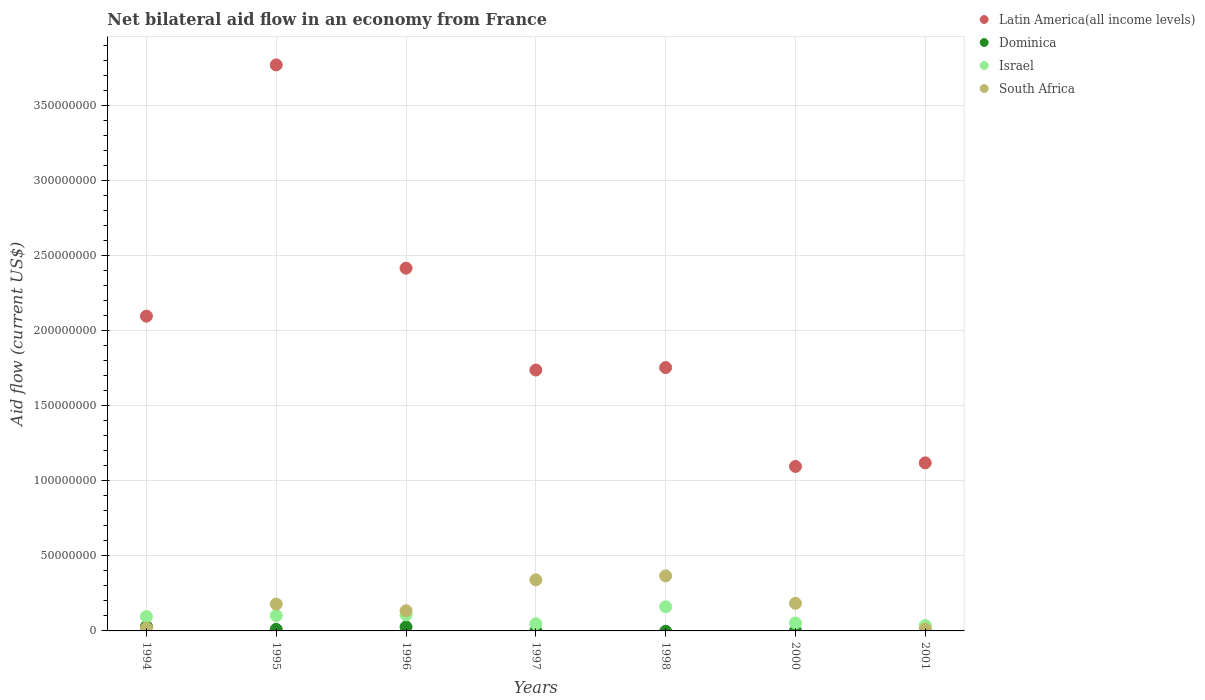How many different coloured dotlines are there?
Provide a succinct answer. 4. What is the net bilateral aid flow in South Africa in 1994?
Offer a terse response. 1.88e+06. Across all years, what is the maximum net bilateral aid flow in Dominica?
Make the answer very short. 2.91e+06. What is the total net bilateral aid flow in Israel in the graph?
Ensure brevity in your answer.  6.02e+07. What is the difference between the net bilateral aid flow in Latin America(all income levels) in 1994 and that in 1998?
Make the answer very short. 3.42e+07. What is the difference between the net bilateral aid flow in Latin America(all income levels) in 1995 and the net bilateral aid flow in Israel in 1997?
Keep it short and to the point. 3.72e+08. What is the average net bilateral aid flow in Latin America(all income levels) per year?
Make the answer very short. 2.00e+08. In the year 1997, what is the difference between the net bilateral aid flow in Dominica and net bilateral aid flow in Israel?
Your answer should be very brief. -4.63e+06. In how many years, is the net bilateral aid flow in South Africa greater than 50000000 US$?
Provide a short and direct response. 0. What is the ratio of the net bilateral aid flow in South Africa in 1997 to that in 1998?
Keep it short and to the point. 0.93. Is the difference between the net bilateral aid flow in Dominica in 1994 and 1995 greater than the difference between the net bilateral aid flow in Israel in 1994 and 1995?
Provide a short and direct response. Yes. What is the difference between the highest and the second highest net bilateral aid flow in South Africa?
Offer a very short reply. 2.65e+06. What is the difference between the highest and the lowest net bilateral aid flow in Israel?
Offer a very short reply. 1.25e+07. In how many years, is the net bilateral aid flow in South Africa greater than the average net bilateral aid flow in South Africa taken over all years?
Keep it short and to the point. 4. Is it the case that in every year, the sum of the net bilateral aid flow in Dominica and net bilateral aid flow in Israel  is greater than the net bilateral aid flow in South Africa?
Your response must be concise. No. Does the net bilateral aid flow in Israel monotonically increase over the years?
Offer a very short reply. No. Is the net bilateral aid flow in Latin America(all income levels) strictly greater than the net bilateral aid flow in Israel over the years?
Provide a short and direct response. Yes. How many years are there in the graph?
Provide a succinct answer. 7. What is the difference between two consecutive major ticks on the Y-axis?
Provide a succinct answer. 5.00e+07. Does the graph contain any zero values?
Offer a terse response. Yes. Does the graph contain grids?
Offer a very short reply. Yes. Where does the legend appear in the graph?
Your answer should be very brief. Top right. How many legend labels are there?
Provide a short and direct response. 4. What is the title of the graph?
Give a very brief answer. Net bilateral aid flow in an economy from France. What is the label or title of the X-axis?
Provide a succinct answer. Years. What is the label or title of the Y-axis?
Make the answer very short. Aid flow (current US$). What is the Aid flow (current US$) in Latin America(all income levels) in 1994?
Offer a very short reply. 2.10e+08. What is the Aid flow (current US$) in Dominica in 1994?
Provide a succinct answer. 2.91e+06. What is the Aid flow (current US$) of Israel in 1994?
Offer a very short reply. 9.57e+06. What is the Aid flow (current US$) in South Africa in 1994?
Offer a terse response. 1.88e+06. What is the Aid flow (current US$) in Latin America(all income levels) in 1995?
Provide a succinct answer. 3.77e+08. What is the Aid flow (current US$) in Dominica in 1995?
Your response must be concise. 1.05e+06. What is the Aid flow (current US$) in Israel in 1995?
Make the answer very short. 1.02e+07. What is the Aid flow (current US$) of South Africa in 1995?
Ensure brevity in your answer.  1.79e+07. What is the Aid flow (current US$) of Latin America(all income levels) in 1996?
Keep it short and to the point. 2.41e+08. What is the Aid flow (current US$) of Dominica in 1996?
Ensure brevity in your answer.  2.66e+06. What is the Aid flow (current US$) of Israel in 1996?
Ensure brevity in your answer.  1.07e+07. What is the Aid flow (current US$) of South Africa in 1996?
Ensure brevity in your answer.  1.34e+07. What is the Aid flow (current US$) in Latin America(all income levels) in 1997?
Offer a very short reply. 1.74e+08. What is the Aid flow (current US$) of Dominica in 1997?
Ensure brevity in your answer.  1.50e+05. What is the Aid flow (current US$) in Israel in 1997?
Offer a very short reply. 4.78e+06. What is the Aid flow (current US$) in South Africa in 1997?
Provide a short and direct response. 3.40e+07. What is the Aid flow (current US$) in Latin America(all income levels) in 1998?
Provide a succinct answer. 1.75e+08. What is the Aid flow (current US$) of Israel in 1998?
Your response must be concise. 1.61e+07. What is the Aid flow (current US$) of South Africa in 1998?
Make the answer very short. 3.67e+07. What is the Aid flow (current US$) of Latin America(all income levels) in 2000?
Your answer should be compact. 1.09e+08. What is the Aid flow (current US$) in Israel in 2000?
Your answer should be compact. 5.28e+06. What is the Aid flow (current US$) in South Africa in 2000?
Offer a very short reply. 1.84e+07. What is the Aid flow (current US$) in Latin America(all income levels) in 2001?
Give a very brief answer. 1.12e+08. What is the Aid flow (current US$) in Dominica in 2001?
Ensure brevity in your answer.  0. What is the Aid flow (current US$) in Israel in 2001?
Offer a terse response. 3.59e+06. What is the Aid flow (current US$) in South Africa in 2001?
Keep it short and to the point. 1.27e+06. Across all years, what is the maximum Aid flow (current US$) of Latin America(all income levels)?
Make the answer very short. 3.77e+08. Across all years, what is the maximum Aid flow (current US$) in Dominica?
Offer a very short reply. 2.91e+06. Across all years, what is the maximum Aid flow (current US$) in Israel?
Your answer should be very brief. 1.61e+07. Across all years, what is the maximum Aid flow (current US$) in South Africa?
Your answer should be very brief. 3.67e+07. Across all years, what is the minimum Aid flow (current US$) of Latin America(all income levels)?
Ensure brevity in your answer.  1.09e+08. Across all years, what is the minimum Aid flow (current US$) of Israel?
Offer a very short reply. 3.59e+06. Across all years, what is the minimum Aid flow (current US$) of South Africa?
Ensure brevity in your answer.  1.27e+06. What is the total Aid flow (current US$) in Latin America(all income levels) in the graph?
Provide a succinct answer. 1.40e+09. What is the total Aid flow (current US$) in Dominica in the graph?
Your answer should be compact. 6.80e+06. What is the total Aid flow (current US$) of Israel in the graph?
Keep it short and to the point. 6.02e+07. What is the total Aid flow (current US$) of South Africa in the graph?
Provide a short and direct response. 1.23e+08. What is the difference between the Aid flow (current US$) of Latin America(all income levels) in 1994 and that in 1995?
Make the answer very short. -1.67e+08. What is the difference between the Aid flow (current US$) of Dominica in 1994 and that in 1995?
Ensure brevity in your answer.  1.86e+06. What is the difference between the Aid flow (current US$) of Israel in 1994 and that in 1995?
Provide a short and direct response. -6.70e+05. What is the difference between the Aid flow (current US$) in South Africa in 1994 and that in 1995?
Your response must be concise. -1.60e+07. What is the difference between the Aid flow (current US$) in Latin America(all income levels) in 1994 and that in 1996?
Keep it short and to the point. -3.19e+07. What is the difference between the Aid flow (current US$) in Israel in 1994 and that in 1996?
Make the answer very short. -1.09e+06. What is the difference between the Aid flow (current US$) of South Africa in 1994 and that in 1996?
Your answer should be compact. -1.15e+07. What is the difference between the Aid flow (current US$) of Latin America(all income levels) in 1994 and that in 1997?
Provide a short and direct response. 3.58e+07. What is the difference between the Aid flow (current US$) in Dominica in 1994 and that in 1997?
Ensure brevity in your answer.  2.76e+06. What is the difference between the Aid flow (current US$) of Israel in 1994 and that in 1997?
Offer a terse response. 4.79e+06. What is the difference between the Aid flow (current US$) in South Africa in 1994 and that in 1997?
Your answer should be compact. -3.21e+07. What is the difference between the Aid flow (current US$) of Latin America(all income levels) in 1994 and that in 1998?
Ensure brevity in your answer.  3.42e+07. What is the difference between the Aid flow (current US$) of Israel in 1994 and that in 1998?
Provide a succinct answer. -6.52e+06. What is the difference between the Aid flow (current US$) of South Africa in 1994 and that in 1998?
Keep it short and to the point. -3.48e+07. What is the difference between the Aid flow (current US$) of Latin America(all income levels) in 1994 and that in 2000?
Provide a short and direct response. 1.00e+08. What is the difference between the Aid flow (current US$) in Dominica in 1994 and that in 2000?
Keep it short and to the point. 2.88e+06. What is the difference between the Aid flow (current US$) in Israel in 1994 and that in 2000?
Give a very brief answer. 4.29e+06. What is the difference between the Aid flow (current US$) in South Africa in 1994 and that in 2000?
Ensure brevity in your answer.  -1.65e+07. What is the difference between the Aid flow (current US$) of Latin America(all income levels) in 1994 and that in 2001?
Your response must be concise. 9.77e+07. What is the difference between the Aid flow (current US$) in Israel in 1994 and that in 2001?
Offer a very short reply. 5.98e+06. What is the difference between the Aid flow (current US$) of Latin America(all income levels) in 1995 and that in 1996?
Ensure brevity in your answer.  1.35e+08. What is the difference between the Aid flow (current US$) in Dominica in 1995 and that in 1996?
Your answer should be compact. -1.61e+06. What is the difference between the Aid flow (current US$) of Israel in 1995 and that in 1996?
Offer a terse response. -4.20e+05. What is the difference between the Aid flow (current US$) of South Africa in 1995 and that in 1996?
Your answer should be very brief. 4.44e+06. What is the difference between the Aid flow (current US$) of Latin America(all income levels) in 1995 and that in 1997?
Give a very brief answer. 2.03e+08. What is the difference between the Aid flow (current US$) in Dominica in 1995 and that in 1997?
Ensure brevity in your answer.  9.00e+05. What is the difference between the Aid flow (current US$) of Israel in 1995 and that in 1997?
Your answer should be very brief. 5.46e+06. What is the difference between the Aid flow (current US$) in South Africa in 1995 and that in 1997?
Ensure brevity in your answer.  -1.62e+07. What is the difference between the Aid flow (current US$) of Latin America(all income levels) in 1995 and that in 1998?
Offer a terse response. 2.01e+08. What is the difference between the Aid flow (current US$) in Israel in 1995 and that in 1998?
Provide a short and direct response. -5.85e+06. What is the difference between the Aid flow (current US$) in South Africa in 1995 and that in 1998?
Give a very brief answer. -1.88e+07. What is the difference between the Aid flow (current US$) of Latin America(all income levels) in 1995 and that in 2000?
Provide a succinct answer. 2.67e+08. What is the difference between the Aid flow (current US$) of Dominica in 1995 and that in 2000?
Make the answer very short. 1.02e+06. What is the difference between the Aid flow (current US$) of Israel in 1995 and that in 2000?
Keep it short and to the point. 4.96e+06. What is the difference between the Aid flow (current US$) in South Africa in 1995 and that in 2000?
Your answer should be compact. -5.00e+05. What is the difference between the Aid flow (current US$) of Latin America(all income levels) in 1995 and that in 2001?
Ensure brevity in your answer.  2.65e+08. What is the difference between the Aid flow (current US$) in Israel in 1995 and that in 2001?
Your answer should be compact. 6.65e+06. What is the difference between the Aid flow (current US$) of South Africa in 1995 and that in 2001?
Ensure brevity in your answer.  1.66e+07. What is the difference between the Aid flow (current US$) in Latin America(all income levels) in 1996 and that in 1997?
Provide a short and direct response. 6.78e+07. What is the difference between the Aid flow (current US$) of Dominica in 1996 and that in 1997?
Make the answer very short. 2.51e+06. What is the difference between the Aid flow (current US$) of Israel in 1996 and that in 1997?
Provide a short and direct response. 5.88e+06. What is the difference between the Aid flow (current US$) of South Africa in 1996 and that in 1997?
Your answer should be compact. -2.06e+07. What is the difference between the Aid flow (current US$) of Latin America(all income levels) in 1996 and that in 1998?
Provide a short and direct response. 6.62e+07. What is the difference between the Aid flow (current US$) of Israel in 1996 and that in 1998?
Ensure brevity in your answer.  -5.43e+06. What is the difference between the Aid flow (current US$) in South Africa in 1996 and that in 1998?
Your response must be concise. -2.32e+07. What is the difference between the Aid flow (current US$) of Latin America(all income levels) in 1996 and that in 2000?
Your answer should be compact. 1.32e+08. What is the difference between the Aid flow (current US$) in Dominica in 1996 and that in 2000?
Offer a very short reply. 2.63e+06. What is the difference between the Aid flow (current US$) in Israel in 1996 and that in 2000?
Your response must be concise. 5.38e+06. What is the difference between the Aid flow (current US$) of South Africa in 1996 and that in 2000?
Your answer should be compact. -4.94e+06. What is the difference between the Aid flow (current US$) in Latin America(all income levels) in 1996 and that in 2001?
Provide a short and direct response. 1.30e+08. What is the difference between the Aid flow (current US$) of Israel in 1996 and that in 2001?
Your response must be concise. 7.07e+06. What is the difference between the Aid flow (current US$) in South Africa in 1996 and that in 2001?
Your answer should be very brief. 1.22e+07. What is the difference between the Aid flow (current US$) of Latin America(all income levels) in 1997 and that in 1998?
Your answer should be compact. -1.63e+06. What is the difference between the Aid flow (current US$) of Israel in 1997 and that in 1998?
Your answer should be very brief. -1.13e+07. What is the difference between the Aid flow (current US$) in South Africa in 1997 and that in 1998?
Provide a short and direct response. -2.65e+06. What is the difference between the Aid flow (current US$) of Latin America(all income levels) in 1997 and that in 2000?
Ensure brevity in your answer.  6.42e+07. What is the difference between the Aid flow (current US$) in Dominica in 1997 and that in 2000?
Keep it short and to the point. 1.20e+05. What is the difference between the Aid flow (current US$) of Israel in 1997 and that in 2000?
Ensure brevity in your answer.  -5.00e+05. What is the difference between the Aid flow (current US$) of South Africa in 1997 and that in 2000?
Offer a very short reply. 1.56e+07. What is the difference between the Aid flow (current US$) of Latin America(all income levels) in 1997 and that in 2001?
Provide a succinct answer. 6.18e+07. What is the difference between the Aid flow (current US$) of Israel in 1997 and that in 2001?
Ensure brevity in your answer.  1.19e+06. What is the difference between the Aid flow (current US$) in South Africa in 1997 and that in 2001?
Your response must be concise. 3.27e+07. What is the difference between the Aid flow (current US$) in Latin America(all income levels) in 1998 and that in 2000?
Your response must be concise. 6.58e+07. What is the difference between the Aid flow (current US$) of Israel in 1998 and that in 2000?
Your answer should be compact. 1.08e+07. What is the difference between the Aid flow (current US$) of South Africa in 1998 and that in 2000?
Offer a terse response. 1.83e+07. What is the difference between the Aid flow (current US$) of Latin America(all income levels) in 1998 and that in 2001?
Ensure brevity in your answer.  6.34e+07. What is the difference between the Aid flow (current US$) in Israel in 1998 and that in 2001?
Offer a very short reply. 1.25e+07. What is the difference between the Aid flow (current US$) in South Africa in 1998 and that in 2001?
Give a very brief answer. 3.54e+07. What is the difference between the Aid flow (current US$) of Latin America(all income levels) in 2000 and that in 2001?
Provide a succinct answer. -2.40e+06. What is the difference between the Aid flow (current US$) of Israel in 2000 and that in 2001?
Ensure brevity in your answer.  1.69e+06. What is the difference between the Aid flow (current US$) in South Africa in 2000 and that in 2001?
Offer a terse response. 1.71e+07. What is the difference between the Aid flow (current US$) in Latin America(all income levels) in 1994 and the Aid flow (current US$) in Dominica in 1995?
Keep it short and to the point. 2.08e+08. What is the difference between the Aid flow (current US$) in Latin America(all income levels) in 1994 and the Aid flow (current US$) in Israel in 1995?
Keep it short and to the point. 1.99e+08. What is the difference between the Aid flow (current US$) in Latin America(all income levels) in 1994 and the Aid flow (current US$) in South Africa in 1995?
Your answer should be very brief. 1.92e+08. What is the difference between the Aid flow (current US$) of Dominica in 1994 and the Aid flow (current US$) of Israel in 1995?
Give a very brief answer. -7.33e+06. What is the difference between the Aid flow (current US$) of Dominica in 1994 and the Aid flow (current US$) of South Africa in 1995?
Your answer should be very brief. -1.50e+07. What is the difference between the Aid flow (current US$) in Israel in 1994 and the Aid flow (current US$) in South Africa in 1995?
Provide a succinct answer. -8.29e+06. What is the difference between the Aid flow (current US$) of Latin America(all income levels) in 1994 and the Aid flow (current US$) of Dominica in 1996?
Offer a very short reply. 2.07e+08. What is the difference between the Aid flow (current US$) in Latin America(all income levels) in 1994 and the Aid flow (current US$) in Israel in 1996?
Offer a terse response. 1.99e+08. What is the difference between the Aid flow (current US$) in Latin America(all income levels) in 1994 and the Aid flow (current US$) in South Africa in 1996?
Offer a very short reply. 1.96e+08. What is the difference between the Aid flow (current US$) of Dominica in 1994 and the Aid flow (current US$) of Israel in 1996?
Give a very brief answer. -7.75e+06. What is the difference between the Aid flow (current US$) of Dominica in 1994 and the Aid flow (current US$) of South Africa in 1996?
Provide a short and direct response. -1.05e+07. What is the difference between the Aid flow (current US$) of Israel in 1994 and the Aid flow (current US$) of South Africa in 1996?
Make the answer very short. -3.85e+06. What is the difference between the Aid flow (current US$) in Latin America(all income levels) in 1994 and the Aid flow (current US$) in Dominica in 1997?
Ensure brevity in your answer.  2.09e+08. What is the difference between the Aid flow (current US$) of Latin America(all income levels) in 1994 and the Aid flow (current US$) of Israel in 1997?
Make the answer very short. 2.05e+08. What is the difference between the Aid flow (current US$) of Latin America(all income levels) in 1994 and the Aid flow (current US$) of South Africa in 1997?
Provide a short and direct response. 1.76e+08. What is the difference between the Aid flow (current US$) of Dominica in 1994 and the Aid flow (current US$) of Israel in 1997?
Ensure brevity in your answer.  -1.87e+06. What is the difference between the Aid flow (current US$) of Dominica in 1994 and the Aid flow (current US$) of South Africa in 1997?
Make the answer very short. -3.11e+07. What is the difference between the Aid flow (current US$) in Israel in 1994 and the Aid flow (current US$) in South Africa in 1997?
Provide a short and direct response. -2.44e+07. What is the difference between the Aid flow (current US$) of Latin America(all income levels) in 1994 and the Aid flow (current US$) of Israel in 1998?
Keep it short and to the point. 1.93e+08. What is the difference between the Aid flow (current US$) of Latin America(all income levels) in 1994 and the Aid flow (current US$) of South Africa in 1998?
Give a very brief answer. 1.73e+08. What is the difference between the Aid flow (current US$) in Dominica in 1994 and the Aid flow (current US$) in Israel in 1998?
Offer a very short reply. -1.32e+07. What is the difference between the Aid flow (current US$) of Dominica in 1994 and the Aid flow (current US$) of South Africa in 1998?
Offer a very short reply. -3.38e+07. What is the difference between the Aid flow (current US$) of Israel in 1994 and the Aid flow (current US$) of South Africa in 1998?
Provide a succinct answer. -2.71e+07. What is the difference between the Aid flow (current US$) of Latin America(all income levels) in 1994 and the Aid flow (current US$) of Dominica in 2000?
Give a very brief answer. 2.10e+08. What is the difference between the Aid flow (current US$) in Latin America(all income levels) in 1994 and the Aid flow (current US$) in Israel in 2000?
Make the answer very short. 2.04e+08. What is the difference between the Aid flow (current US$) in Latin America(all income levels) in 1994 and the Aid flow (current US$) in South Africa in 2000?
Your answer should be compact. 1.91e+08. What is the difference between the Aid flow (current US$) of Dominica in 1994 and the Aid flow (current US$) of Israel in 2000?
Your answer should be very brief. -2.37e+06. What is the difference between the Aid flow (current US$) of Dominica in 1994 and the Aid flow (current US$) of South Africa in 2000?
Offer a very short reply. -1.54e+07. What is the difference between the Aid flow (current US$) of Israel in 1994 and the Aid flow (current US$) of South Africa in 2000?
Provide a short and direct response. -8.79e+06. What is the difference between the Aid flow (current US$) of Latin America(all income levels) in 1994 and the Aid flow (current US$) of Israel in 2001?
Your response must be concise. 2.06e+08. What is the difference between the Aid flow (current US$) in Latin America(all income levels) in 1994 and the Aid flow (current US$) in South Africa in 2001?
Ensure brevity in your answer.  2.08e+08. What is the difference between the Aid flow (current US$) of Dominica in 1994 and the Aid flow (current US$) of Israel in 2001?
Your answer should be very brief. -6.80e+05. What is the difference between the Aid flow (current US$) of Dominica in 1994 and the Aid flow (current US$) of South Africa in 2001?
Keep it short and to the point. 1.64e+06. What is the difference between the Aid flow (current US$) of Israel in 1994 and the Aid flow (current US$) of South Africa in 2001?
Offer a terse response. 8.30e+06. What is the difference between the Aid flow (current US$) in Latin America(all income levels) in 1995 and the Aid flow (current US$) in Dominica in 1996?
Provide a succinct answer. 3.74e+08. What is the difference between the Aid flow (current US$) of Latin America(all income levels) in 1995 and the Aid flow (current US$) of Israel in 1996?
Keep it short and to the point. 3.66e+08. What is the difference between the Aid flow (current US$) in Latin America(all income levels) in 1995 and the Aid flow (current US$) in South Africa in 1996?
Your response must be concise. 3.63e+08. What is the difference between the Aid flow (current US$) of Dominica in 1995 and the Aid flow (current US$) of Israel in 1996?
Your response must be concise. -9.61e+06. What is the difference between the Aid flow (current US$) in Dominica in 1995 and the Aid flow (current US$) in South Africa in 1996?
Ensure brevity in your answer.  -1.24e+07. What is the difference between the Aid flow (current US$) of Israel in 1995 and the Aid flow (current US$) of South Africa in 1996?
Provide a short and direct response. -3.18e+06. What is the difference between the Aid flow (current US$) in Latin America(all income levels) in 1995 and the Aid flow (current US$) in Dominica in 1997?
Your answer should be compact. 3.77e+08. What is the difference between the Aid flow (current US$) of Latin America(all income levels) in 1995 and the Aid flow (current US$) of Israel in 1997?
Keep it short and to the point. 3.72e+08. What is the difference between the Aid flow (current US$) of Latin America(all income levels) in 1995 and the Aid flow (current US$) of South Africa in 1997?
Give a very brief answer. 3.43e+08. What is the difference between the Aid flow (current US$) of Dominica in 1995 and the Aid flow (current US$) of Israel in 1997?
Provide a short and direct response. -3.73e+06. What is the difference between the Aid flow (current US$) of Dominica in 1995 and the Aid flow (current US$) of South Africa in 1997?
Offer a very short reply. -3.30e+07. What is the difference between the Aid flow (current US$) in Israel in 1995 and the Aid flow (current US$) in South Africa in 1997?
Your answer should be very brief. -2.38e+07. What is the difference between the Aid flow (current US$) of Latin America(all income levels) in 1995 and the Aid flow (current US$) of Israel in 1998?
Your answer should be very brief. 3.61e+08. What is the difference between the Aid flow (current US$) of Latin America(all income levels) in 1995 and the Aid flow (current US$) of South Africa in 1998?
Provide a short and direct response. 3.40e+08. What is the difference between the Aid flow (current US$) in Dominica in 1995 and the Aid flow (current US$) in Israel in 1998?
Provide a short and direct response. -1.50e+07. What is the difference between the Aid flow (current US$) in Dominica in 1995 and the Aid flow (current US$) in South Africa in 1998?
Offer a very short reply. -3.56e+07. What is the difference between the Aid flow (current US$) of Israel in 1995 and the Aid flow (current US$) of South Africa in 1998?
Make the answer very short. -2.64e+07. What is the difference between the Aid flow (current US$) in Latin America(all income levels) in 1995 and the Aid flow (current US$) in Dominica in 2000?
Offer a very short reply. 3.77e+08. What is the difference between the Aid flow (current US$) in Latin America(all income levels) in 1995 and the Aid flow (current US$) in Israel in 2000?
Your answer should be compact. 3.72e+08. What is the difference between the Aid flow (current US$) in Latin America(all income levels) in 1995 and the Aid flow (current US$) in South Africa in 2000?
Provide a short and direct response. 3.58e+08. What is the difference between the Aid flow (current US$) of Dominica in 1995 and the Aid flow (current US$) of Israel in 2000?
Offer a very short reply. -4.23e+06. What is the difference between the Aid flow (current US$) of Dominica in 1995 and the Aid flow (current US$) of South Africa in 2000?
Keep it short and to the point. -1.73e+07. What is the difference between the Aid flow (current US$) of Israel in 1995 and the Aid flow (current US$) of South Africa in 2000?
Provide a succinct answer. -8.12e+06. What is the difference between the Aid flow (current US$) in Latin America(all income levels) in 1995 and the Aid flow (current US$) in Israel in 2001?
Offer a very short reply. 3.73e+08. What is the difference between the Aid flow (current US$) of Latin America(all income levels) in 1995 and the Aid flow (current US$) of South Africa in 2001?
Your response must be concise. 3.76e+08. What is the difference between the Aid flow (current US$) of Dominica in 1995 and the Aid flow (current US$) of Israel in 2001?
Offer a terse response. -2.54e+06. What is the difference between the Aid flow (current US$) in Dominica in 1995 and the Aid flow (current US$) in South Africa in 2001?
Your answer should be very brief. -2.20e+05. What is the difference between the Aid flow (current US$) of Israel in 1995 and the Aid flow (current US$) of South Africa in 2001?
Ensure brevity in your answer.  8.97e+06. What is the difference between the Aid flow (current US$) of Latin America(all income levels) in 1996 and the Aid flow (current US$) of Dominica in 1997?
Your answer should be very brief. 2.41e+08. What is the difference between the Aid flow (current US$) in Latin America(all income levels) in 1996 and the Aid flow (current US$) in Israel in 1997?
Provide a succinct answer. 2.37e+08. What is the difference between the Aid flow (current US$) in Latin America(all income levels) in 1996 and the Aid flow (current US$) in South Africa in 1997?
Your answer should be very brief. 2.07e+08. What is the difference between the Aid flow (current US$) in Dominica in 1996 and the Aid flow (current US$) in Israel in 1997?
Your answer should be very brief. -2.12e+06. What is the difference between the Aid flow (current US$) in Dominica in 1996 and the Aid flow (current US$) in South Africa in 1997?
Offer a terse response. -3.14e+07. What is the difference between the Aid flow (current US$) in Israel in 1996 and the Aid flow (current US$) in South Africa in 1997?
Make the answer very short. -2.34e+07. What is the difference between the Aid flow (current US$) in Latin America(all income levels) in 1996 and the Aid flow (current US$) in Israel in 1998?
Keep it short and to the point. 2.25e+08. What is the difference between the Aid flow (current US$) of Latin America(all income levels) in 1996 and the Aid flow (current US$) of South Africa in 1998?
Provide a short and direct response. 2.05e+08. What is the difference between the Aid flow (current US$) of Dominica in 1996 and the Aid flow (current US$) of Israel in 1998?
Your answer should be compact. -1.34e+07. What is the difference between the Aid flow (current US$) in Dominica in 1996 and the Aid flow (current US$) in South Africa in 1998?
Give a very brief answer. -3.40e+07. What is the difference between the Aid flow (current US$) in Israel in 1996 and the Aid flow (current US$) in South Africa in 1998?
Offer a terse response. -2.60e+07. What is the difference between the Aid flow (current US$) of Latin America(all income levels) in 1996 and the Aid flow (current US$) of Dominica in 2000?
Give a very brief answer. 2.41e+08. What is the difference between the Aid flow (current US$) of Latin America(all income levels) in 1996 and the Aid flow (current US$) of Israel in 2000?
Offer a terse response. 2.36e+08. What is the difference between the Aid flow (current US$) in Latin America(all income levels) in 1996 and the Aid flow (current US$) in South Africa in 2000?
Give a very brief answer. 2.23e+08. What is the difference between the Aid flow (current US$) in Dominica in 1996 and the Aid flow (current US$) in Israel in 2000?
Ensure brevity in your answer.  -2.62e+06. What is the difference between the Aid flow (current US$) in Dominica in 1996 and the Aid flow (current US$) in South Africa in 2000?
Keep it short and to the point. -1.57e+07. What is the difference between the Aid flow (current US$) in Israel in 1996 and the Aid flow (current US$) in South Africa in 2000?
Your answer should be compact. -7.70e+06. What is the difference between the Aid flow (current US$) in Latin America(all income levels) in 1996 and the Aid flow (current US$) in Israel in 2001?
Offer a terse response. 2.38e+08. What is the difference between the Aid flow (current US$) in Latin America(all income levels) in 1996 and the Aid flow (current US$) in South Africa in 2001?
Make the answer very short. 2.40e+08. What is the difference between the Aid flow (current US$) in Dominica in 1996 and the Aid flow (current US$) in Israel in 2001?
Keep it short and to the point. -9.30e+05. What is the difference between the Aid flow (current US$) in Dominica in 1996 and the Aid flow (current US$) in South Africa in 2001?
Keep it short and to the point. 1.39e+06. What is the difference between the Aid flow (current US$) of Israel in 1996 and the Aid flow (current US$) of South Africa in 2001?
Ensure brevity in your answer.  9.39e+06. What is the difference between the Aid flow (current US$) in Latin America(all income levels) in 1997 and the Aid flow (current US$) in Israel in 1998?
Your answer should be compact. 1.58e+08. What is the difference between the Aid flow (current US$) in Latin America(all income levels) in 1997 and the Aid flow (current US$) in South Africa in 1998?
Provide a short and direct response. 1.37e+08. What is the difference between the Aid flow (current US$) of Dominica in 1997 and the Aid flow (current US$) of Israel in 1998?
Your response must be concise. -1.59e+07. What is the difference between the Aid flow (current US$) of Dominica in 1997 and the Aid flow (current US$) of South Africa in 1998?
Offer a terse response. -3.65e+07. What is the difference between the Aid flow (current US$) in Israel in 1997 and the Aid flow (current US$) in South Africa in 1998?
Your response must be concise. -3.19e+07. What is the difference between the Aid flow (current US$) in Latin America(all income levels) in 1997 and the Aid flow (current US$) in Dominica in 2000?
Ensure brevity in your answer.  1.74e+08. What is the difference between the Aid flow (current US$) in Latin America(all income levels) in 1997 and the Aid flow (current US$) in Israel in 2000?
Your answer should be compact. 1.68e+08. What is the difference between the Aid flow (current US$) in Latin America(all income levels) in 1997 and the Aid flow (current US$) in South Africa in 2000?
Make the answer very short. 1.55e+08. What is the difference between the Aid flow (current US$) of Dominica in 1997 and the Aid flow (current US$) of Israel in 2000?
Provide a succinct answer. -5.13e+06. What is the difference between the Aid flow (current US$) of Dominica in 1997 and the Aid flow (current US$) of South Africa in 2000?
Ensure brevity in your answer.  -1.82e+07. What is the difference between the Aid flow (current US$) in Israel in 1997 and the Aid flow (current US$) in South Africa in 2000?
Your response must be concise. -1.36e+07. What is the difference between the Aid flow (current US$) in Latin America(all income levels) in 1997 and the Aid flow (current US$) in Israel in 2001?
Offer a very short reply. 1.70e+08. What is the difference between the Aid flow (current US$) of Latin America(all income levels) in 1997 and the Aid flow (current US$) of South Africa in 2001?
Keep it short and to the point. 1.72e+08. What is the difference between the Aid flow (current US$) in Dominica in 1997 and the Aid flow (current US$) in Israel in 2001?
Your answer should be compact. -3.44e+06. What is the difference between the Aid flow (current US$) in Dominica in 1997 and the Aid flow (current US$) in South Africa in 2001?
Give a very brief answer. -1.12e+06. What is the difference between the Aid flow (current US$) of Israel in 1997 and the Aid flow (current US$) of South Africa in 2001?
Give a very brief answer. 3.51e+06. What is the difference between the Aid flow (current US$) in Latin America(all income levels) in 1998 and the Aid flow (current US$) in Dominica in 2000?
Keep it short and to the point. 1.75e+08. What is the difference between the Aid flow (current US$) of Latin America(all income levels) in 1998 and the Aid flow (current US$) of Israel in 2000?
Offer a very short reply. 1.70e+08. What is the difference between the Aid flow (current US$) in Latin America(all income levels) in 1998 and the Aid flow (current US$) in South Africa in 2000?
Keep it short and to the point. 1.57e+08. What is the difference between the Aid flow (current US$) of Israel in 1998 and the Aid flow (current US$) of South Africa in 2000?
Provide a short and direct response. -2.27e+06. What is the difference between the Aid flow (current US$) in Latin America(all income levels) in 1998 and the Aid flow (current US$) in Israel in 2001?
Offer a very short reply. 1.72e+08. What is the difference between the Aid flow (current US$) of Latin America(all income levels) in 1998 and the Aid flow (current US$) of South Africa in 2001?
Provide a short and direct response. 1.74e+08. What is the difference between the Aid flow (current US$) in Israel in 1998 and the Aid flow (current US$) in South Africa in 2001?
Your response must be concise. 1.48e+07. What is the difference between the Aid flow (current US$) of Latin America(all income levels) in 2000 and the Aid flow (current US$) of Israel in 2001?
Provide a succinct answer. 1.06e+08. What is the difference between the Aid flow (current US$) of Latin America(all income levels) in 2000 and the Aid flow (current US$) of South Africa in 2001?
Provide a succinct answer. 1.08e+08. What is the difference between the Aid flow (current US$) of Dominica in 2000 and the Aid flow (current US$) of Israel in 2001?
Ensure brevity in your answer.  -3.56e+06. What is the difference between the Aid flow (current US$) in Dominica in 2000 and the Aid flow (current US$) in South Africa in 2001?
Make the answer very short. -1.24e+06. What is the difference between the Aid flow (current US$) in Israel in 2000 and the Aid flow (current US$) in South Africa in 2001?
Your response must be concise. 4.01e+06. What is the average Aid flow (current US$) of Latin America(all income levels) per year?
Provide a short and direct response. 2.00e+08. What is the average Aid flow (current US$) in Dominica per year?
Ensure brevity in your answer.  9.71e+05. What is the average Aid flow (current US$) of Israel per year?
Offer a very short reply. 8.60e+06. What is the average Aid flow (current US$) of South Africa per year?
Offer a terse response. 1.76e+07. In the year 1994, what is the difference between the Aid flow (current US$) of Latin America(all income levels) and Aid flow (current US$) of Dominica?
Keep it short and to the point. 2.07e+08. In the year 1994, what is the difference between the Aid flow (current US$) of Latin America(all income levels) and Aid flow (current US$) of Israel?
Keep it short and to the point. 2.00e+08. In the year 1994, what is the difference between the Aid flow (current US$) in Latin America(all income levels) and Aid flow (current US$) in South Africa?
Your answer should be compact. 2.08e+08. In the year 1994, what is the difference between the Aid flow (current US$) of Dominica and Aid flow (current US$) of Israel?
Ensure brevity in your answer.  -6.66e+06. In the year 1994, what is the difference between the Aid flow (current US$) of Dominica and Aid flow (current US$) of South Africa?
Give a very brief answer. 1.03e+06. In the year 1994, what is the difference between the Aid flow (current US$) of Israel and Aid flow (current US$) of South Africa?
Offer a terse response. 7.69e+06. In the year 1995, what is the difference between the Aid flow (current US$) in Latin America(all income levels) and Aid flow (current US$) in Dominica?
Provide a short and direct response. 3.76e+08. In the year 1995, what is the difference between the Aid flow (current US$) in Latin America(all income levels) and Aid flow (current US$) in Israel?
Your answer should be compact. 3.67e+08. In the year 1995, what is the difference between the Aid flow (current US$) of Latin America(all income levels) and Aid flow (current US$) of South Africa?
Offer a very short reply. 3.59e+08. In the year 1995, what is the difference between the Aid flow (current US$) of Dominica and Aid flow (current US$) of Israel?
Keep it short and to the point. -9.19e+06. In the year 1995, what is the difference between the Aid flow (current US$) of Dominica and Aid flow (current US$) of South Africa?
Provide a succinct answer. -1.68e+07. In the year 1995, what is the difference between the Aid flow (current US$) in Israel and Aid flow (current US$) in South Africa?
Ensure brevity in your answer.  -7.62e+06. In the year 1996, what is the difference between the Aid flow (current US$) in Latin America(all income levels) and Aid flow (current US$) in Dominica?
Make the answer very short. 2.39e+08. In the year 1996, what is the difference between the Aid flow (current US$) in Latin America(all income levels) and Aid flow (current US$) in Israel?
Ensure brevity in your answer.  2.31e+08. In the year 1996, what is the difference between the Aid flow (current US$) of Latin America(all income levels) and Aid flow (current US$) of South Africa?
Provide a short and direct response. 2.28e+08. In the year 1996, what is the difference between the Aid flow (current US$) of Dominica and Aid flow (current US$) of Israel?
Provide a short and direct response. -8.00e+06. In the year 1996, what is the difference between the Aid flow (current US$) of Dominica and Aid flow (current US$) of South Africa?
Your response must be concise. -1.08e+07. In the year 1996, what is the difference between the Aid flow (current US$) of Israel and Aid flow (current US$) of South Africa?
Offer a very short reply. -2.76e+06. In the year 1997, what is the difference between the Aid flow (current US$) of Latin America(all income levels) and Aid flow (current US$) of Dominica?
Offer a terse response. 1.74e+08. In the year 1997, what is the difference between the Aid flow (current US$) in Latin America(all income levels) and Aid flow (current US$) in Israel?
Ensure brevity in your answer.  1.69e+08. In the year 1997, what is the difference between the Aid flow (current US$) of Latin America(all income levels) and Aid flow (current US$) of South Africa?
Provide a short and direct response. 1.40e+08. In the year 1997, what is the difference between the Aid flow (current US$) of Dominica and Aid flow (current US$) of Israel?
Your answer should be very brief. -4.63e+06. In the year 1997, what is the difference between the Aid flow (current US$) in Dominica and Aid flow (current US$) in South Africa?
Your answer should be very brief. -3.39e+07. In the year 1997, what is the difference between the Aid flow (current US$) of Israel and Aid flow (current US$) of South Africa?
Your answer should be compact. -2.92e+07. In the year 1998, what is the difference between the Aid flow (current US$) of Latin America(all income levels) and Aid flow (current US$) of Israel?
Provide a short and direct response. 1.59e+08. In the year 1998, what is the difference between the Aid flow (current US$) of Latin America(all income levels) and Aid flow (current US$) of South Africa?
Your answer should be compact. 1.39e+08. In the year 1998, what is the difference between the Aid flow (current US$) in Israel and Aid flow (current US$) in South Africa?
Your answer should be very brief. -2.06e+07. In the year 2000, what is the difference between the Aid flow (current US$) in Latin America(all income levels) and Aid flow (current US$) in Dominica?
Your answer should be very brief. 1.09e+08. In the year 2000, what is the difference between the Aid flow (current US$) of Latin America(all income levels) and Aid flow (current US$) of Israel?
Offer a very short reply. 1.04e+08. In the year 2000, what is the difference between the Aid flow (current US$) in Latin America(all income levels) and Aid flow (current US$) in South Africa?
Provide a succinct answer. 9.11e+07. In the year 2000, what is the difference between the Aid flow (current US$) of Dominica and Aid flow (current US$) of Israel?
Your response must be concise. -5.25e+06. In the year 2000, what is the difference between the Aid flow (current US$) in Dominica and Aid flow (current US$) in South Africa?
Your answer should be compact. -1.83e+07. In the year 2000, what is the difference between the Aid flow (current US$) of Israel and Aid flow (current US$) of South Africa?
Your response must be concise. -1.31e+07. In the year 2001, what is the difference between the Aid flow (current US$) in Latin America(all income levels) and Aid flow (current US$) in Israel?
Offer a terse response. 1.08e+08. In the year 2001, what is the difference between the Aid flow (current US$) in Latin America(all income levels) and Aid flow (current US$) in South Africa?
Your answer should be compact. 1.11e+08. In the year 2001, what is the difference between the Aid flow (current US$) in Israel and Aid flow (current US$) in South Africa?
Provide a short and direct response. 2.32e+06. What is the ratio of the Aid flow (current US$) of Latin America(all income levels) in 1994 to that in 1995?
Your answer should be compact. 0.56. What is the ratio of the Aid flow (current US$) in Dominica in 1994 to that in 1995?
Keep it short and to the point. 2.77. What is the ratio of the Aid flow (current US$) in Israel in 1994 to that in 1995?
Ensure brevity in your answer.  0.93. What is the ratio of the Aid flow (current US$) in South Africa in 1994 to that in 1995?
Offer a very short reply. 0.11. What is the ratio of the Aid flow (current US$) in Latin America(all income levels) in 1994 to that in 1996?
Provide a short and direct response. 0.87. What is the ratio of the Aid flow (current US$) of Dominica in 1994 to that in 1996?
Make the answer very short. 1.09. What is the ratio of the Aid flow (current US$) in Israel in 1994 to that in 1996?
Offer a very short reply. 0.9. What is the ratio of the Aid flow (current US$) of South Africa in 1994 to that in 1996?
Keep it short and to the point. 0.14. What is the ratio of the Aid flow (current US$) in Latin America(all income levels) in 1994 to that in 1997?
Make the answer very short. 1.21. What is the ratio of the Aid flow (current US$) in Dominica in 1994 to that in 1997?
Your answer should be compact. 19.4. What is the ratio of the Aid flow (current US$) of Israel in 1994 to that in 1997?
Give a very brief answer. 2. What is the ratio of the Aid flow (current US$) in South Africa in 1994 to that in 1997?
Offer a very short reply. 0.06. What is the ratio of the Aid flow (current US$) in Latin America(all income levels) in 1994 to that in 1998?
Offer a terse response. 1.2. What is the ratio of the Aid flow (current US$) in Israel in 1994 to that in 1998?
Offer a very short reply. 0.59. What is the ratio of the Aid flow (current US$) in South Africa in 1994 to that in 1998?
Make the answer very short. 0.05. What is the ratio of the Aid flow (current US$) in Latin America(all income levels) in 1994 to that in 2000?
Offer a terse response. 1.91. What is the ratio of the Aid flow (current US$) in Dominica in 1994 to that in 2000?
Your response must be concise. 97. What is the ratio of the Aid flow (current US$) in Israel in 1994 to that in 2000?
Offer a terse response. 1.81. What is the ratio of the Aid flow (current US$) in South Africa in 1994 to that in 2000?
Your answer should be compact. 0.1. What is the ratio of the Aid flow (current US$) in Latin America(all income levels) in 1994 to that in 2001?
Your answer should be very brief. 1.87. What is the ratio of the Aid flow (current US$) of Israel in 1994 to that in 2001?
Your response must be concise. 2.67. What is the ratio of the Aid flow (current US$) of South Africa in 1994 to that in 2001?
Give a very brief answer. 1.48. What is the ratio of the Aid flow (current US$) of Latin America(all income levels) in 1995 to that in 1996?
Your answer should be very brief. 1.56. What is the ratio of the Aid flow (current US$) of Dominica in 1995 to that in 1996?
Keep it short and to the point. 0.39. What is the ratio of the Aid flow (current US$) of Israel in 1995 to that in 1996?
Ensure brevity in your answer.  0.96. What is the ratio of the Aid flow (current US$) of South Africa in 1995 to that in 1996?
Ensure brevity in your answer.  1.33. What is the ratio of the Aid flow (current US$) in Latin America(all income levels) in 1995 to that in 1997?
Ensure brevity in your answer.  2.17. What is the ratio of the Aid flow (current US$) of Dominica in 1995 to that in 1997?
Your answer should be very brief. 7. What is the ratio of the Aid flow (current US$) in Israel in 1995 to that in 1997?
Ensure brevity in your answer.  2.14. What is the ratio of the Aid flow (current US$) in South Africa in 1995 to that in 1997?
Make the answer very short. 0.53. What is the ratio of the Aid flow (current US$) of Latin America(all income levels) in 1995 to that in 1998?
Offer a very short reply. 2.15. What is the ratio of the Aid flow (current US$) in Israel in 1995 to that in 1998?
Your answer should be very brief. 0.64. What is the ratio of the Aid flow (current US$) in South Africa in 1995 to that in 1998?
Keep it short and to the point. 0.49. What is the ratio of the Aid flow (current US$) in Latin America(all income levels) in 1995 to that in 2000?
Offer a very short reply. 3.44. What is the ratio of the Aid flow (current US$) in Dominica in 1995 to that in 2000?
Your answer should be compact. 35. What is the ratio of the Aid flow (current US$) in Israel in 1995 to that in 2000?
Provide a short and direct response. 1.94. What is the ratio of the Aid flow (current US$) of South Africa in 1995 to that in 2000?
Keep it short and to the point. 0.97. What is the ratio of the Aid flow (current US$) in Latin America(all income levels) in 1995 to that in 2001?
Give a very brief answer. 3.37. What is the ratio of the Aid flow (current US$) in Israel in 1995 to that in 2001?
Your answer should be very brief. 2.85. What is the ratio of the Aid flow (current US$) of South Africa in 1995 to that in 2001?
Provide a succinct answer. 14.06. What is the ratio of the Aid flow (current US$) of Latin America(all income levels) in 1996 to that in 1997?
Provide a short and direct response. 1.39. What is the ratio of the Aid flow (current US$) in Dominica in 1996 to that in 1997?
Your answer should be compact. 17.73. What is the ratio of the Aid flow (current US$) of Israel in 1996 to that in 1997?
Keep it short and to the point. 2.23. What is the ratio of the Aid flow (current US$) in South Africa in 1996 to that in 1997?
Keep it short and to the point. 0.39. What is the ratio of the Aid flow (current US$) of Latin America(all income levels) in 1996 to that in 1998?
Offer a very short reply. 1.38. What is the ratio of the Aid flow (current US$) of Israel in 1996 to that in 1998?
Provide a succinct answer. 0.66. What is the ratio of the Aid flow (current US$) of South Africa in 1996 to that in 1998?
Keep it short and to the point. 0.37. What is the ratio of the Aid flow (current US$) of Latin America(all income levels) in 1996 to that in 2000?
Offer a terse response. 2.21. What is the ratio of the Aid flow (current US$) in Dominica in 1996 to that in 2000?
Your answer should be compact. 88.67. What is the ratio of the Aid flow (current US$) of Israel in 1996 to that in 2000?
Keep it short and to the point. 2.02. What is the ratio of the Aid flow (current US$) in South Africa in 1996 to that in 2000?
Ensure brevity in your answer.  0.73. What is the ratio of the Aid flow (current US$) of Latin America(all income levels) in 1996 to that in 2001?
Offer a very short reply. 2.16. What is the ratio of the Aid flow (current US$) of Israel in 1996 to that in 2001?
Ensure brevity in your answer.  2.97. What is the ratio of the Aid flow (current US$) in South Africa in 1996 to that in 2001?
Offer a terse response. 10.57. What is the ratio of the Aid flow (current US$) in Israel in 1997 to that in 1998?
Your answer should be compact. 0.3. What is the ratio of the Aid flow (current US$) in South Africa in 1997 to that in 1998?
Make the answer very short. 0.93. What is the ratio of the Aid flow (current US$) in Latin America(all income levels) in 1997 to that in 2000?
Provide a short and direct response. 1.59. What is the ratio of the Aid flow (current US$) of Israel in 1997 to that in 2000?
Make the answer very short. 0.91. What is the ratio of the Aid flow (current US$) in South Africa in 1997 to that in 2000?
Provide a short and direct response. 1.85. What is the ratio of the Aid flow (current US$) of Latin America(all income levels) in 1997 to that in 2001?
Offer a terse response. 1.55. What is the ratio of the Aid flow (current US$) of Israel in 1997 to that in 2001?
Your answer should be compact. 1.33. What is the ratio of the Aid flow (current US$) of South Africa in 1997 to that in 2001?
Your answer should be compact. 26.78. What is the ratio of the Aid flow (current US$) of Latin America(all income levels) in 1998 to that in 2000?
Your answer should be very brief. 1.6. What is the ratio of the Aid flow (current US$) in Israel in 1998 to that in 2000?
Your answer should be compact. 3.05. What is the ratio of the Aid flow (current US$) in South Africa in 1998 to that in 2000?
Provide a succinct answer. 2. What is the ratio of the Aid flow (current US$) of Latin America(all income levels) in 1998 to that in 2001?
Offer a very short reply. 1.57. What is the ratio of the Aid flow (current US$) of Israel in 1998 to that in 2001?
Give a very brief answer. 4.48. What is the ratio of the Aid flow (current US$) of South Africa in 1998 to that in 2001?
Offer a very short reply. 28.87. What is the ratio of the Aid flow (current US$) of Latin America(all income levels) in 2000 to that in 2001?
Offer a terse response. 0.98. What is the ratio of the Aid flow (current US$) in Israel in 2000 to that in 2001?
Your response must be concise. 1.47. What is the ratio of the Aid flow (current US$) of South Africa in 2000 to that in 2001?
Make the answer very short. 14.46. What is the difference between the highest and the second highest Aid flow (current US$) in Latin America(all income levels)?
Provide a succinct answer. 1.35e+08. What is the difference between the highest and the second highest Aid flow (current US$) in Dominica?
Provide a succinct answer. 2.50e+05. What is the difference between the highest and the second highest Aid flow (current US$) in Israel?
Your answer should be compact. 5.43e+06. What is the difference between the highest and the second highest Aid flow (current US$) in South Africa?
Offer a terse response. 2.65e+06. What is the difference between the highest and the lowest Aid flow (current US$) in Latin America(all income levels)?
Make the answer very short. 2.67e+08. What is the difference between the highest and the lowest Aid flow (current US$) in Dominica?
Your answer should be very brief. 2.91e+06. What is the difference between the highest and the lowest Aid flow (current US$) in Israel?
Provide a short and direct response. 1.25e+07. What is the difference between the highest and the lowest Aid flow (current US$) in South Africa?
Your answer should be very brief. 3.54e+07. 